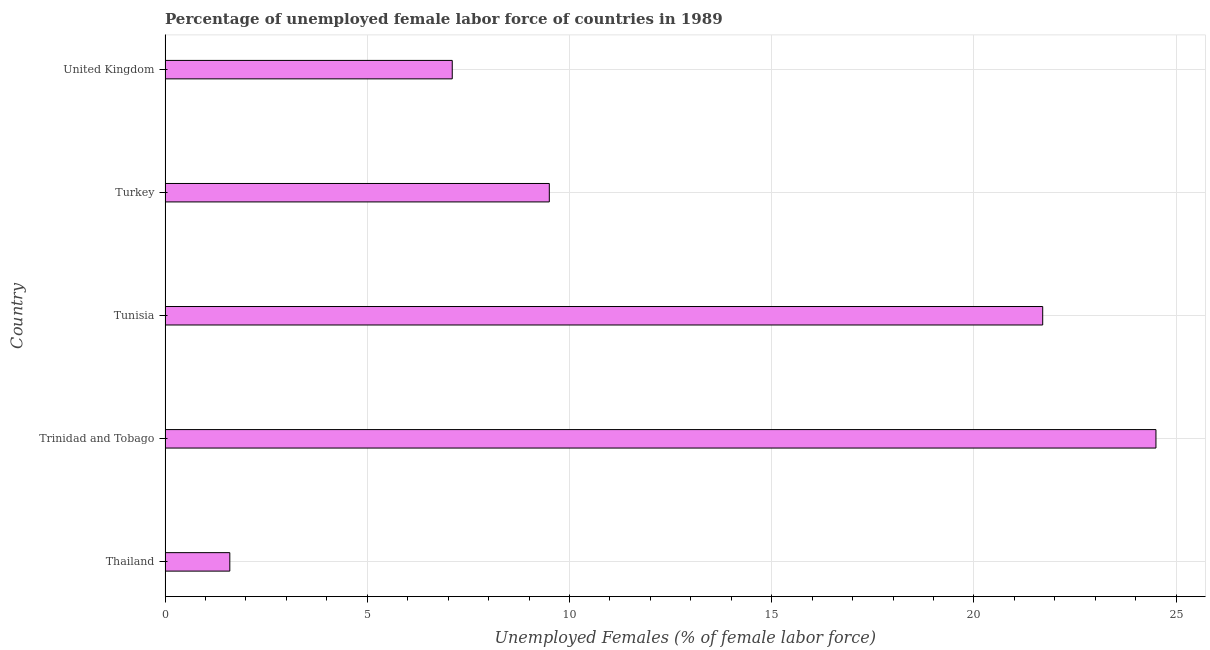Does the graph contain any zero values?
Offer a very short reply. No. What is the title of the graph?
Provide a succinct answer. Percentage of unemployed female labor force of countries in 1989. What is the label or title of the X-axis?
Make the answer very short. Unemployed Females (% of female labor force). What is the label or title of the Y-axis?
Give a very brief answer. Country. What is the total unemployed female labour force in United Kingdom?
Make the answer very short. 7.1. Across all countries, what is the minimum total unemployed female labour force?
Offer a terse response. 1.6. In which country was the total unemployed female labour force maximum?
Make the answer very short. Trinidad and Tobago. In which country was the total unemployed female labour force minimum?
Provide a short and direct response. Thailand. What is the sum of the total unemployed female labour force?
Make the answer very short. 64.4. What is the average total unemployed female labour force per country?
Offer a very short reply. 12.88. In how many countries, is the total unemployed female labour force greater than 10 %?
Offer a very short reply. 2. What is the ratio of the total unemployed female labour force in Tunisia to that in United Kingdom?
Offer a very short reply. 3.06. Is the total unemployed female labour force in Thailand less than that in Tunisia?
Ensure brevity in your answer.  Yes. Is the difference between the total unemployed female labour force in Tunisia and Turkey greater than the difference between any two countries?
Ensure brevity in your answer.  No. What is the difference between the highest and the second highest total unemployed female labour force?
Make the answer very short. 2.8. What is the difference between the highest and the lowest total unemployed female labour force?
Provide a succinct answer. 22.9. In how many countries, is the total unemployed female labour force greater than the average total unemployed female labour force taken over all countries?
Make the answer very short. 2. How many bars are there?
Ensure brevity in your answer.  5. What is the difference between two consecutive major ticks on the X-axis?
Ensure brevity in your answer.  5. Are the values on the major ticks of X-axis written in scientific E-notation?
Keep it short and to the point. No. What is the Unemployed Females (% of female labor force) in Thailand?
Make the answer very short. 1.6. What is the Unemployed Females (% of female labor force) of Tunisia?
Ensure brevity in your answer.  21.7. What is the Unemployed Females (% of female labor force) of Turkey?
Your response must be concise. 9.5. What is the Unemployed Females (% of female labor force) in United Kingdom?
Give a very brief answer. 7.1. What is the difference between the Unemployed Females (% of female labor force) in Thailand and Trinidad and Tobago?
Your answer should be compact. -22.9. What is the difference between the Unemployed Females (% of female labor force) in Thailand and Tunisia?
Give a very brief answer. -20.1. What is the difference between the Unemployed Females (% of female labor force) in Trinidad and Tobago and Tunisia?
Offer a very short reply. 2.8. What is the difference between the Unemployed Females (% of female labor force) in Trinidad and Tobago and Turkey?
Offer a very short reply. 15. What is the ratio of the Unemployed Females (% of female labor force) in Thailand to that in Trinidad and Tobago?
Provide a succinct answer. 0.07. What is the ratio of the Unemployed Females (% of female labor force) in Thailand to that in Tunisia?
Your answer should be very brief. 0.07. What is the ratio of the Unemployed Females (% of female labor force) in Thailand to that in Turkey?
Offer a terse response. 0.17. What is the ratio of the Unemployed Females (% of female labor force) in Thailand to that in United Kingdom?
Make the answer very short. 0.23. What is the ratio of the Unemployed Females (% of female labor force) in Trinidad and Tobago to that in Tunisia?
Offer a very short reply. 1.13. What is the ratio of the Unemployed Females (% of female labor force) in Trinidad and Tobago to that in Turkey?
Offer a terse response. 2.58. What is the ratio of the Unemployed Females (% of female labor force) in Trinidad and Tobago to that in United Kingdom?
Keep it short and to the point. 3.45. What is the ratio of the Unemployed Females (% of female labor force) in Tunisia to that in Turkey?
Make the answer very short. 2.28. What is the ratio of the Unemployed Females (% of female labor force) in Tunisia to that in United Kingdom?
Offer a very short reply. 3.06. What is the ratio of the Unemployed Females (% of female labor force) in Turkey to that in United Kingdom?
Offer a terse response. 1.34. 